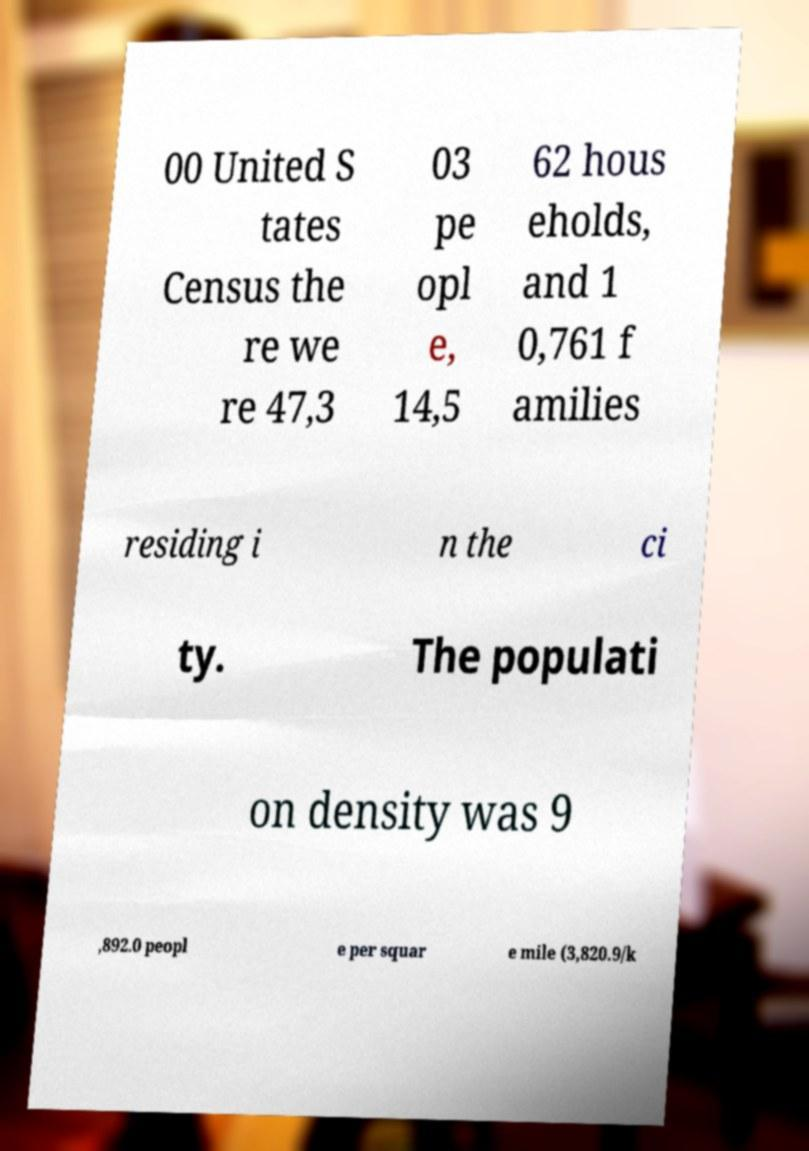There's text embedded in this image that I need extracted. Can you transcribe it verbatim? 00 United S tates Census the re we re 47,3 03 pe opl e, 14,5 62 hous eholds, and 1 0,761 f amilies residing i n the ci ty. The populati on density was 9 ,892.0 peopl e per squar e mile (3,820.9/k 